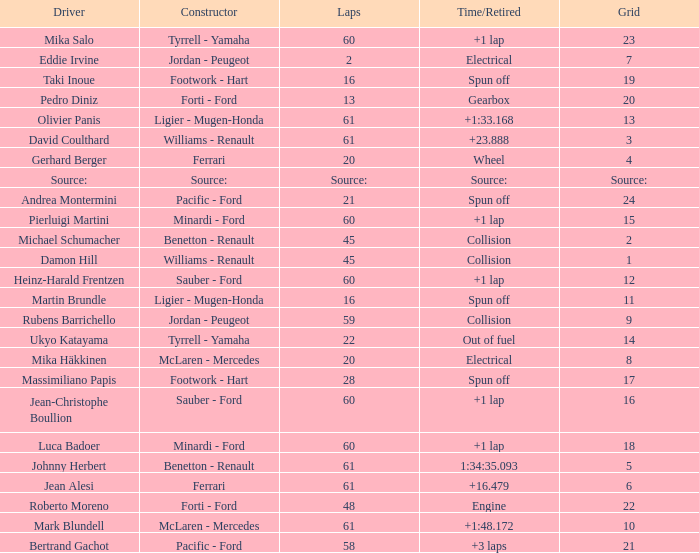What's the time/retired for constructor source:? Source:. Could you parse the entire table? {'header': ['Driver', 'Constructor', 'Laps', 'Time/Retired', 'Grid'], 'rows': [['Mika Salo', 'Tyrrell - Yamaha', '60', '+1 lap', '23'], ['Eddie Irvine', 'Jordan - Peugeot', '2', 'Electrical', '7'], ['Taki Inoue', 'Footwork - Hart', '16', 'Spun off', '19'], ['Pedro Diniz', 'Forti - Ford', '13', 'Gearbox', '20'], ['Olivier Panis', 'Ligier - Mugen-Honda', '61', '+1:33.168', '13'], ['David Coulthard', 'Williams - Renault', '61', '+23.888', '3'], ['Gerhard Berger', 'Ferrari', '20', 'Wheel', '4'], ['Source:', 'Source:', 'Source:', 'Source:', 'Source:'], ['Andrea Montermini', 'Pacific - Ford', '21', 'Spun off', '24'], ['Pierluigi Martini', 'Minardi - Ford', '60', '+1 lap', '15'], ['Michael Schumacher', 'Benetton - Renault', '45', 'Collision', '2'], ['Damon Hill', 'Williams - Renault', '45', 'Collision', '1'], ['Heinz-Harald Frentzen', 'Sauber - Ford', '60', '+1 lap', '12'], ['Martin Brundle', 'Ligier - Mugen-Honda', '16', 'Spun off', '11'], ['Rubens Barrichello', 'Jordan - Peugeot', '59', 'Collision', '9'], ['Ukyo Katayama', 'Tyrrell - Yamaha', '22', 'Out of fuel', '14'], ['Mika Häkkinen', 'McLaren - Mercedes', '20', 'Electrical', '8'], ['Massimiliano Papis', 'Footwork - Hart', '28', 'Spun off', '17'], ['Jean-Christophe Boullion', 'Sauber - Ford', '60', '+1 lap', '16'], ['Luca Badoer', 'Minardi - Ford', '60', '+1 lap', '18'], ['Johnny Herbert', 'Benetton - Renault', '61', '1:34:35.093', '5'], ['Jean Alesi', 'Ferrari', '61', '+16.479', '6'], ['Roberto Moreno', 'Forti - Ford', '48', 'Engine', '22'], ['Mark Blundell', 'McLaren - Mercedes', '61', '+1:48.172', '10'], ['Bertrand Gachot', 'Pacific - Ford', '58', '+3 laps', '21']]} 